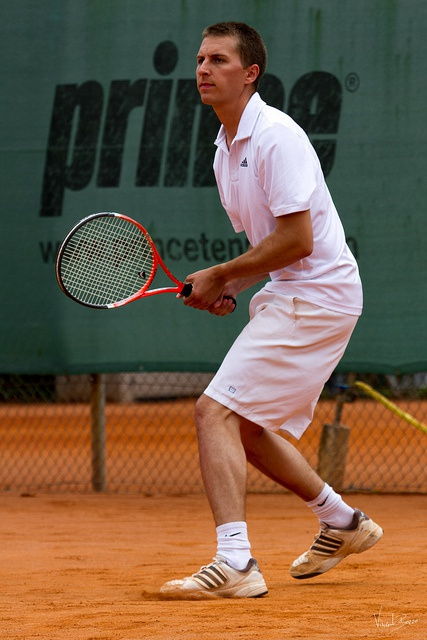Describe the objects in this image and their specific colors. I can see people in teal, lavender, salmon, maroon, and lightpink tones and tennis racket in teal, gray, darkgray, and black tones in this image. 